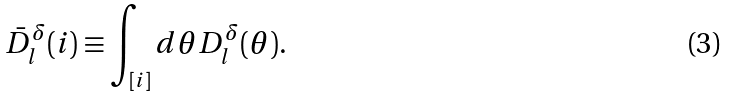Convert formula to latex. <formula><loc_0><loc_0><loc_500><loc_500>\bar { D } _ { l } ^ { \delta } ( i ) \equiv \int _ { [ i ] } d \theta D _ { l } ^ { \delta } ( \theta ) .</formula> 